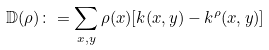Convert formula to latex. <formula><loc_0><loc_0><loc_500><loc_500>\mathbb { D } ( \rho ) \colon = \sum _ { x , y } \rho ( x ) [ k ( x , y ) - k ^ { \rho } ( x , y ) ]</formula> 